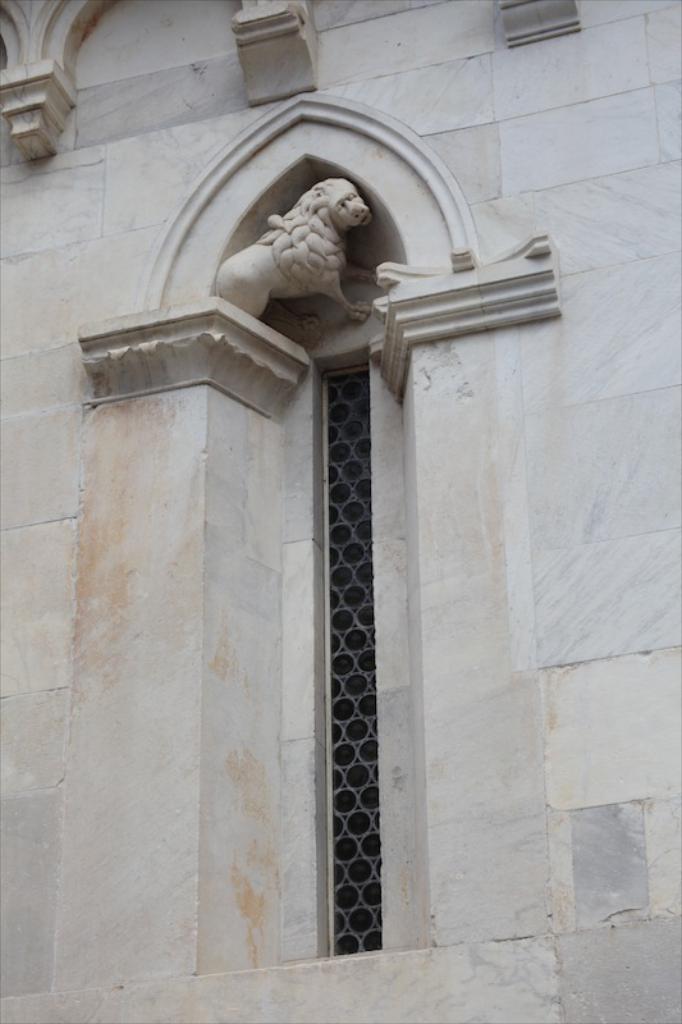In one or two sentences, can you explain what this image depicts? In this image, we can see the wall with window fence. We can also see a sculpture on the wall. 